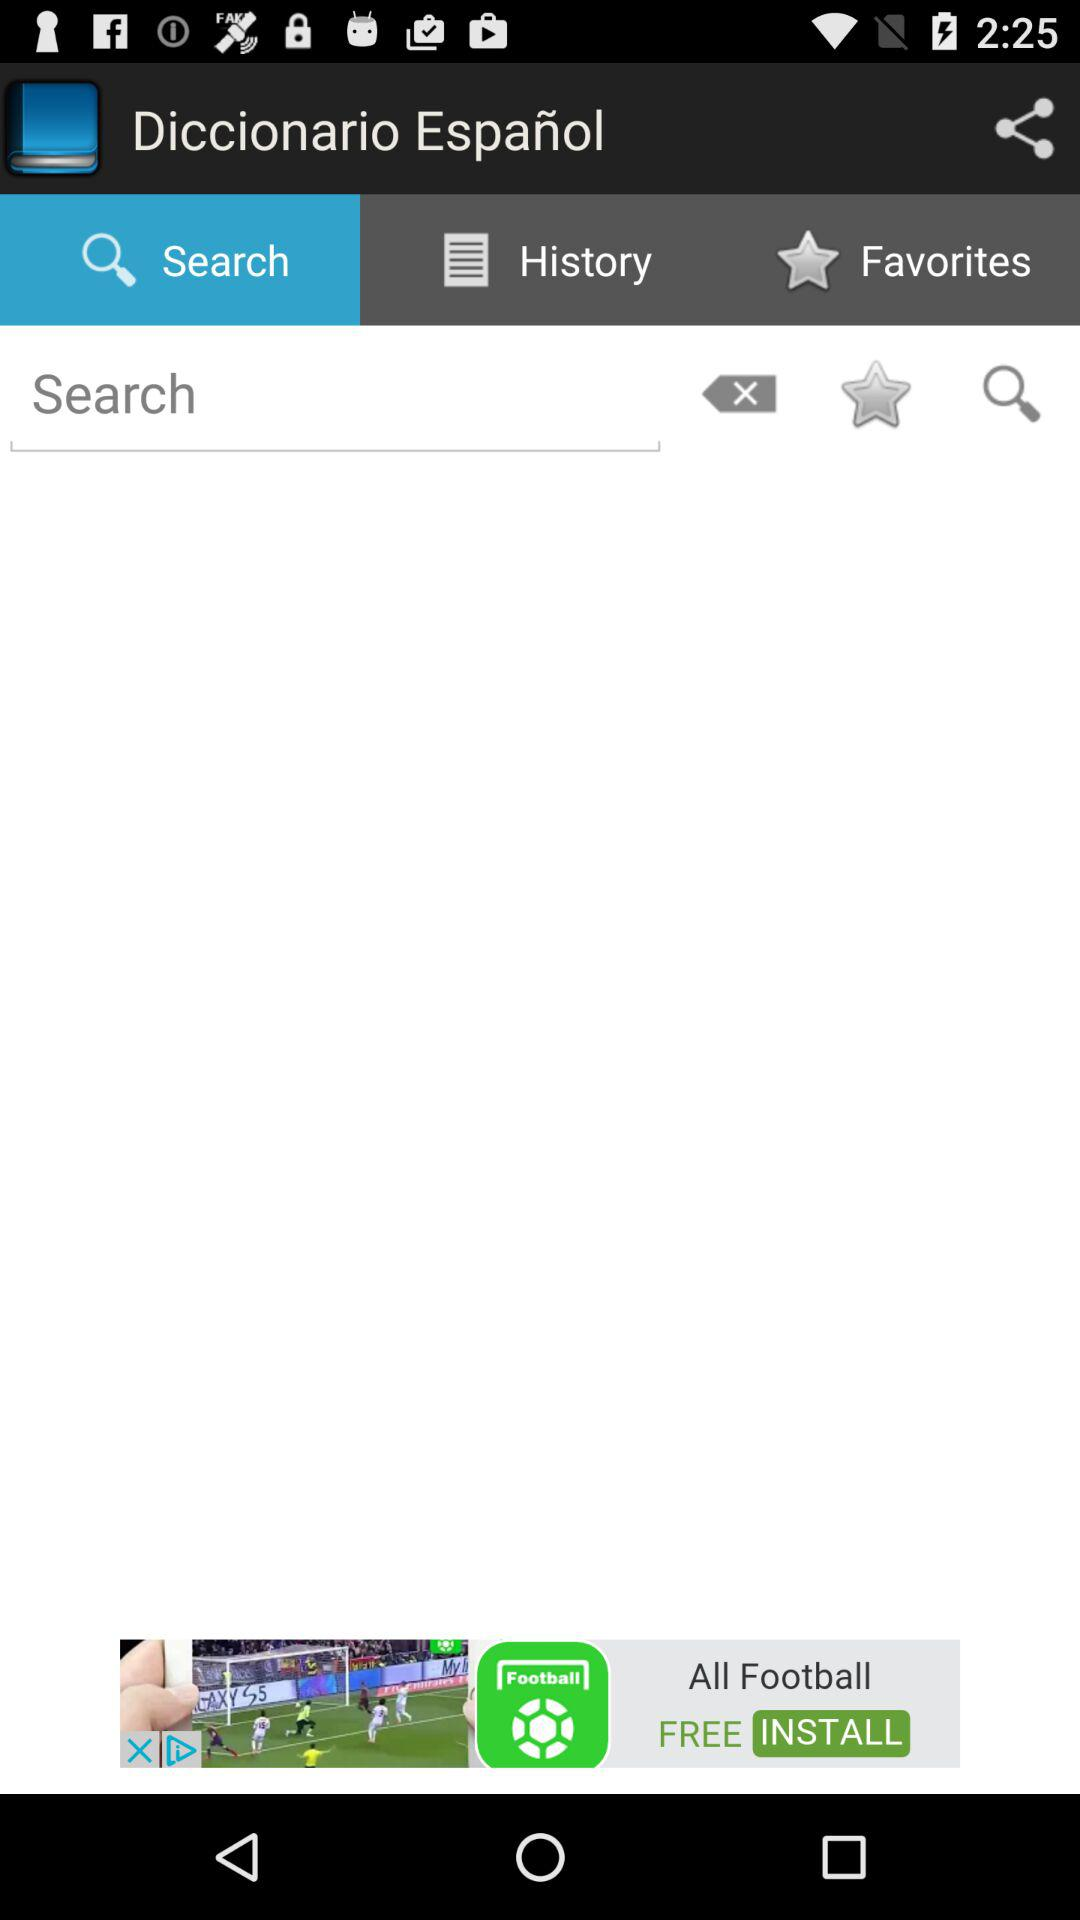Which tab is selected? The selected tab is "Search". 